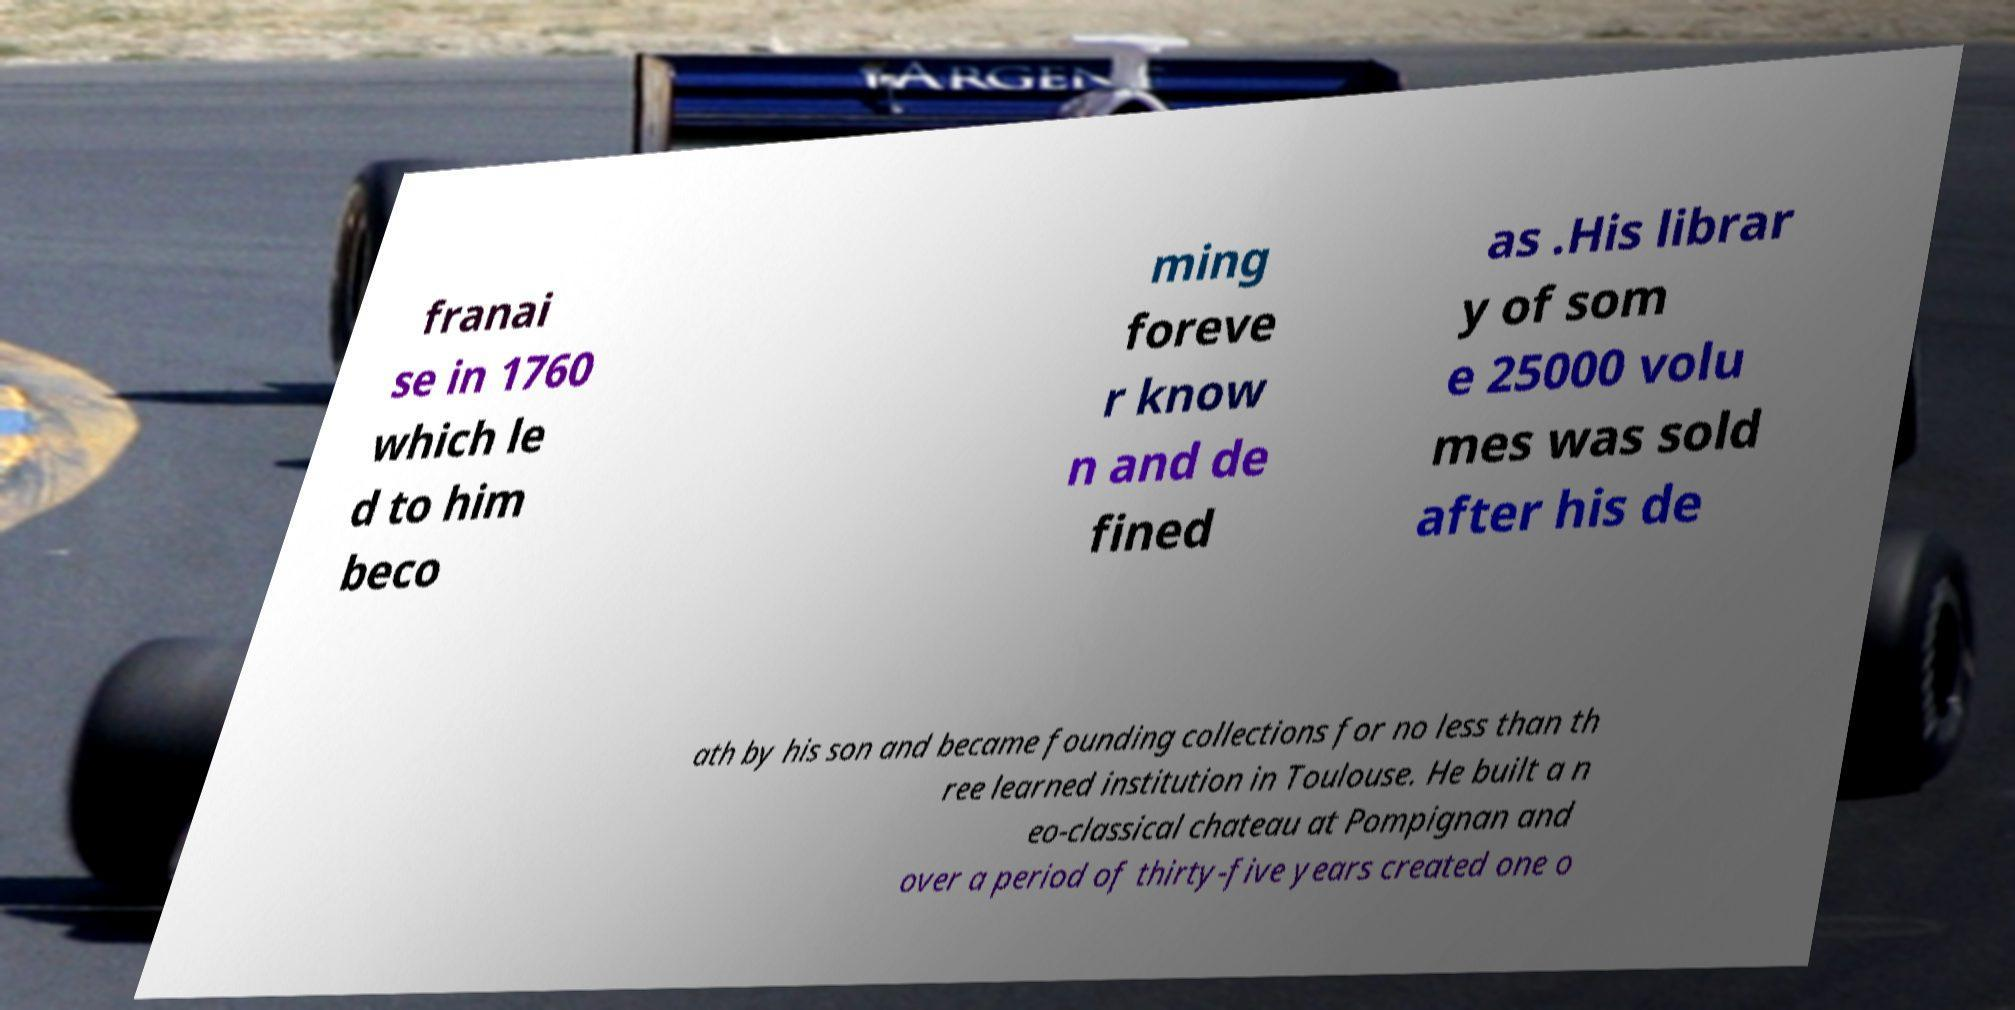For documentation purposes, I need the text within this image transcribed. Could you provide that? franai se in 1760 which le d to him beco ming foreve r know n and de fined as .His librar y of som e 25000 volu mes was sold after his de ath by his son and became founding collections for no less than th ree learned institution in Toulouse. He built a n eo-classical chateau at Pompignan and over a period of thirty-five years created one o 